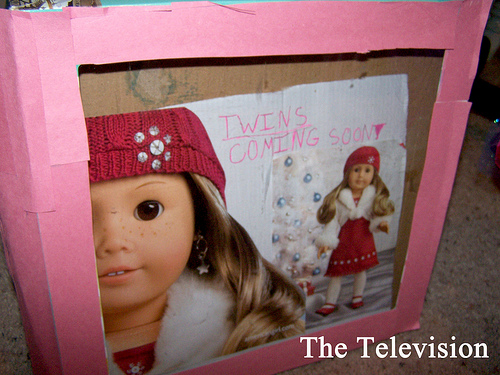<image>
Is there a hat on the doll? No. The hat is not positioned on the doll. They may be near each other, but the hat is not supported by or resting on top of the doll. 